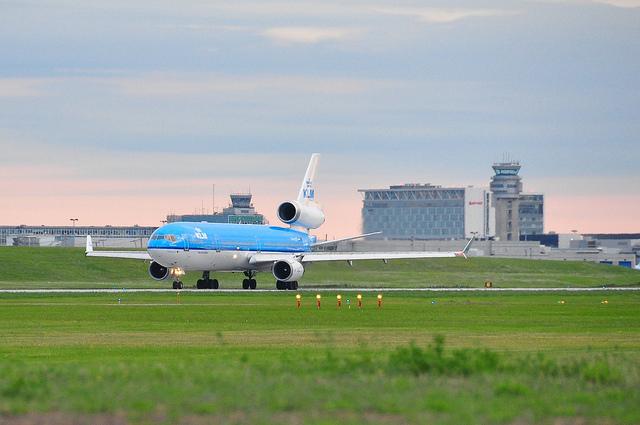What aircraft is this?
Short answer required. Plane. What color is the plane?
Short answer required. Blue and white. What color is the plane?
Write a very short answer. Blue and white. 